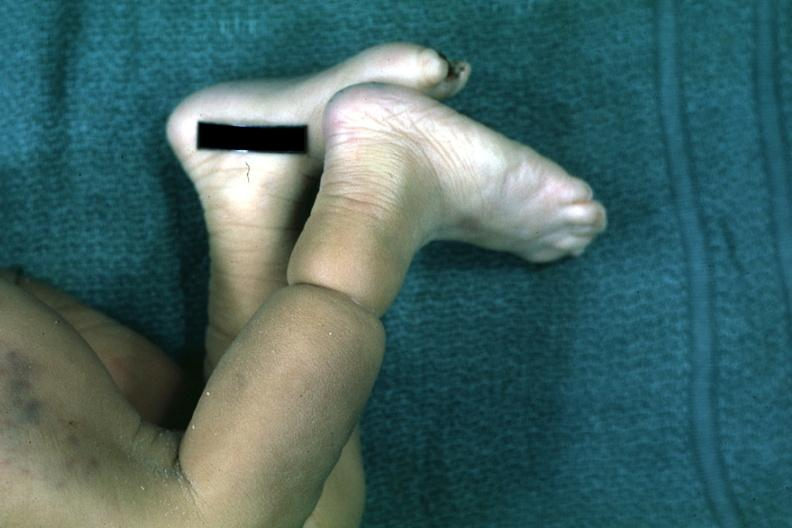s mesothelioma present?
Answer the question using a single word or phrase. No 